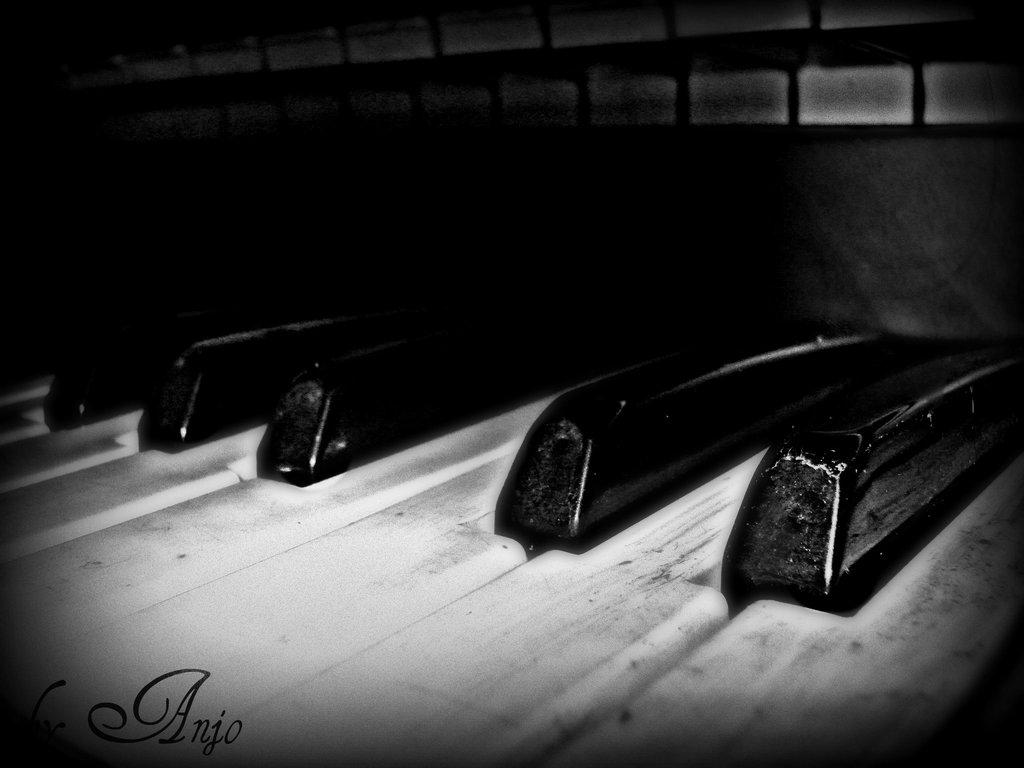What musical instrument is present in the image? There is a piano in the image. What type of rake is being used to play the piano in the image? There is no rake present in the image, and the piano is not being played with a rake. 